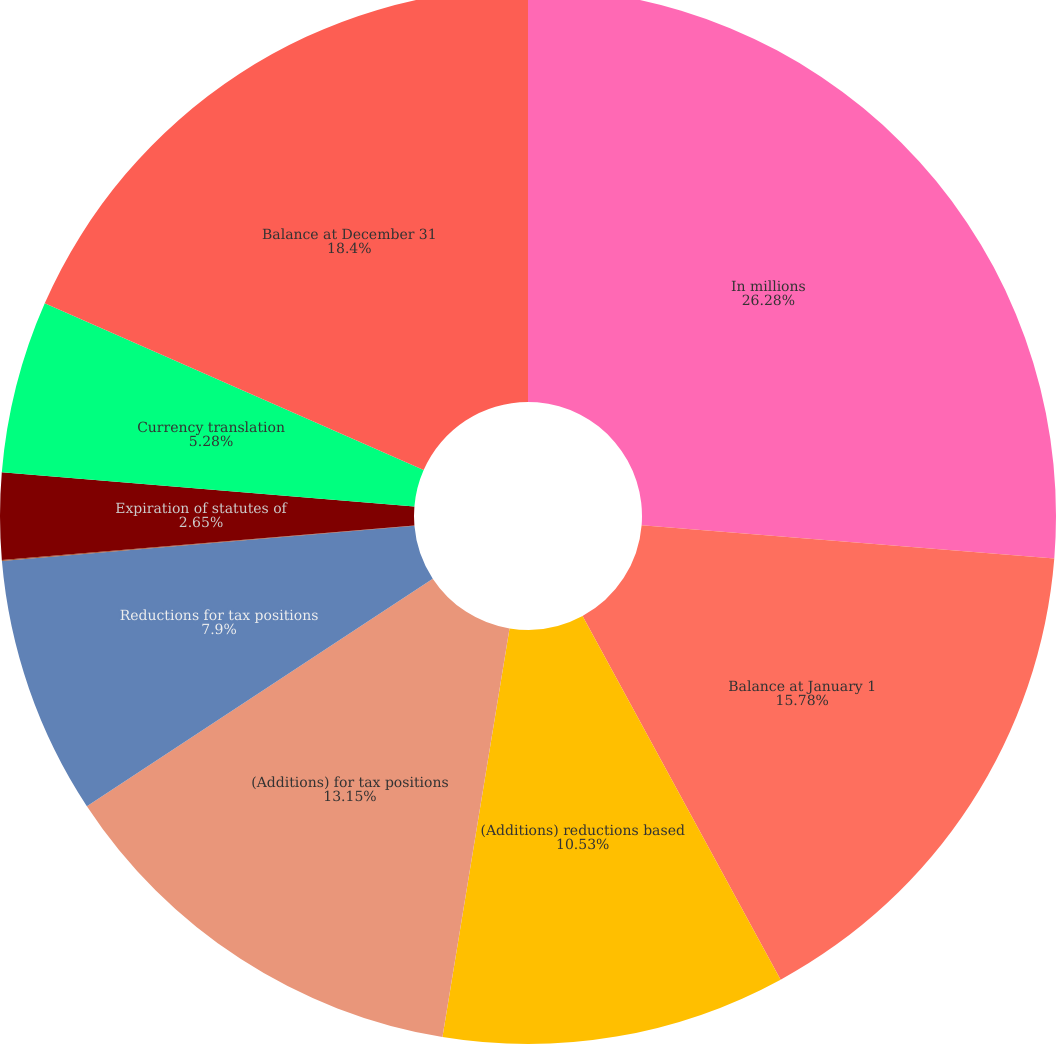Convert chart to OTSL. <chart><loc_0><loc_0><loc_500><loc_500><pie_chart><fcel>In millions<fcel>Balance at January 1<fcel>(Additions) reductions based<fcel>(Additions) for tax positions<fcel>Reductions for tax positions<fcel>Settlements<fcel>Expiration of statutes of<fcel>Currency translation<fcel>Balance at December 31<nl><fcel>26.28%<fcel>15.78%<fcel>10.53%<fcel>13.15%<fcel>7.9%<fcel>0.03%<fcel>2.65%<fcel>5.28%<fcel>18.4%<nl></chart> 